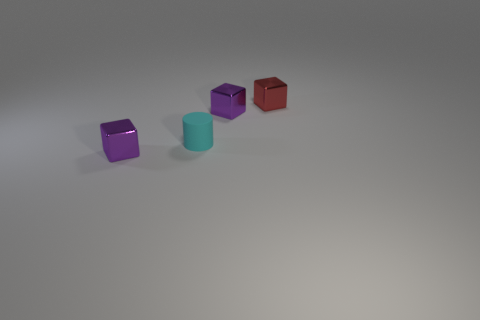Add 3 yellow metallic cylinders. How many objects exist? 7 Subtract all cubes. How many objects are left? 1 Add 1 big purple matte cubes. How many big purple matte cubes exist? 1 Subtract 0 yellow spheres. How many objects are left? 4 Subtract all cylinders. Subtract all small purple metallic blocks. How many objects are left? 1 Add 2 tiny red blocks. How many tiny red blocks are left? 3 